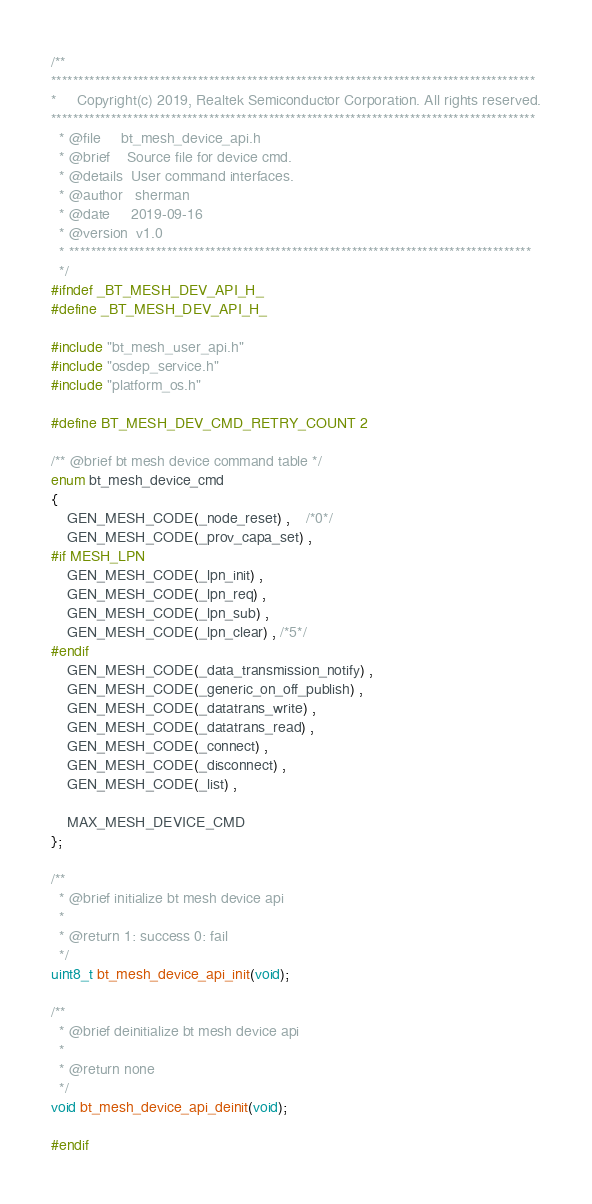<code> <loc_0><loc_0><loc_500><loc_500><_C_>/**
*****************************************************************************************
*     Copyright(c) 2019, Realtek Semiconductor Corporation. All rights reserved.
*****************************************************************************************
  * @file     bt_mesh_device_api.h
  * @brief    Source file for device cmd.
  * @details  User command interfaces.
  * @author   sherman
  * @date     2019-09-16
  * @version  v1.0
  * *************************************************************************************
  */
#ifndef _BT_MESH_DEV_API_H_
#define _BT_MESH_DEV_API_H_

#include "bt_mesh_user_api.h"
#include "osdep_service.h"
#include "platform_os.h"

#define BT_MESH_DEV_CMD_RETRY_COUNT 2

/** @brief bt mesh device command table */
enum bt_mesh_device_cmd
{
    GEN_MESH_CODE(_node_reset) ,	/*0*/
 	GEN_MESH_CODE(_prov_capa_set) , 
#if MESH_LPN
 	GEN_MESH_CODE(_lpn_init) , 
	GEN_MESH_CODE(_lpn_req) , 
	GEN_MESH_CODE(_lpn_sub) ,  
	GEN_MESH_CODE(_lpn_clear) , /*5*/
#endif
    GEN_MESH_CODE(_data_transmission_notify) ,
    GEN_MESH_CODE(_generic_on_off_publish) ,
    GEN_MESH_CODE(_datatrans_write) ,
    GEN_MESH_CODE(_datatrans_read) ,
    GEN_MESH_CODE(_connect) ,
 	GEN_MESH_CODE(_disconnect) ,
    GEN_MESH_CODE(_list) ,
	
	MAX_MESH_DEVICE_CMD
};

/**
  * @brief initialize bt mesh device api
  *
  * @return 1: success 0: fail
  */
uint8_t bt_mesh_device_api_init(void);

/**
  * @brief deinitialize bt mesh device api
  *
  * @return none
  */
void bt_mesh_device_api_deinit(void);

#endif


</code> 